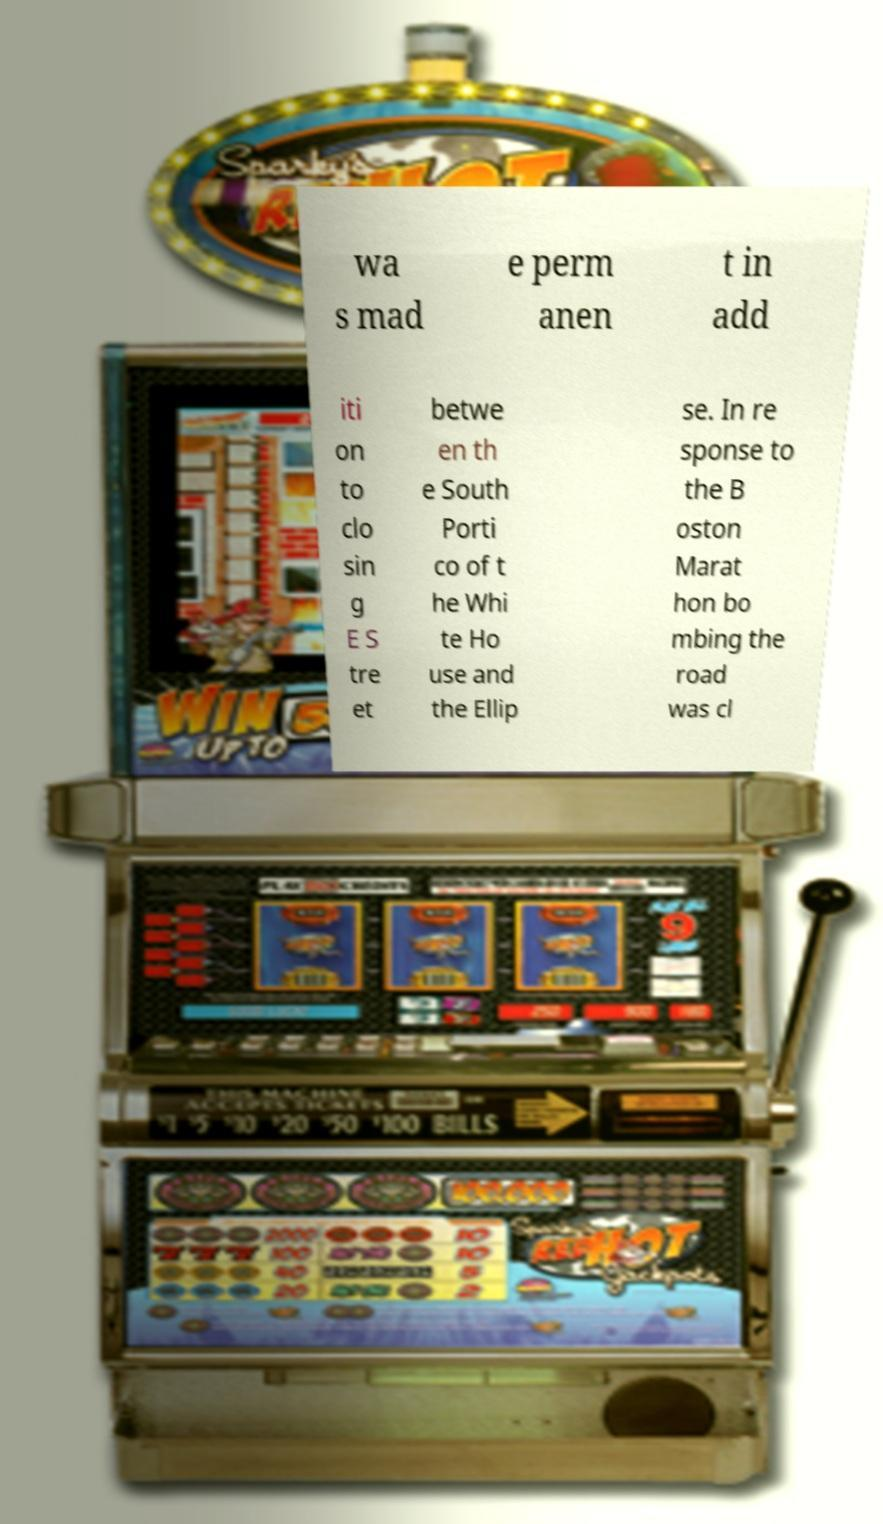Could you extract and type out the text from this image? wa s mad e perm anen t in add iti on to clo sin g E S tre et betwe en th e South Porti co of t he Whi te Ho use and the Ellip se. In re sponse to the B oston Marat hon bo mbing the road was cl 